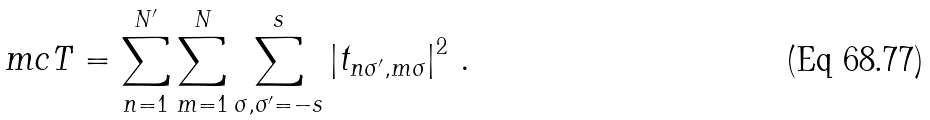Convert formula to latex. <formula><loc_0><loc_0><loc_500><loc_500>\ m c T = \sum _ { n = 1 } ^ { N ^ { \prime } } \sum _ { m = 1 } ^ { N } \sum _ { \sigma , \sigma ^ { \prime } = - s } ^ { s } \left | t _ { n \sigma ^ { \prime } , m \sigma } \right | ^ { 2 } \, .</formula> 